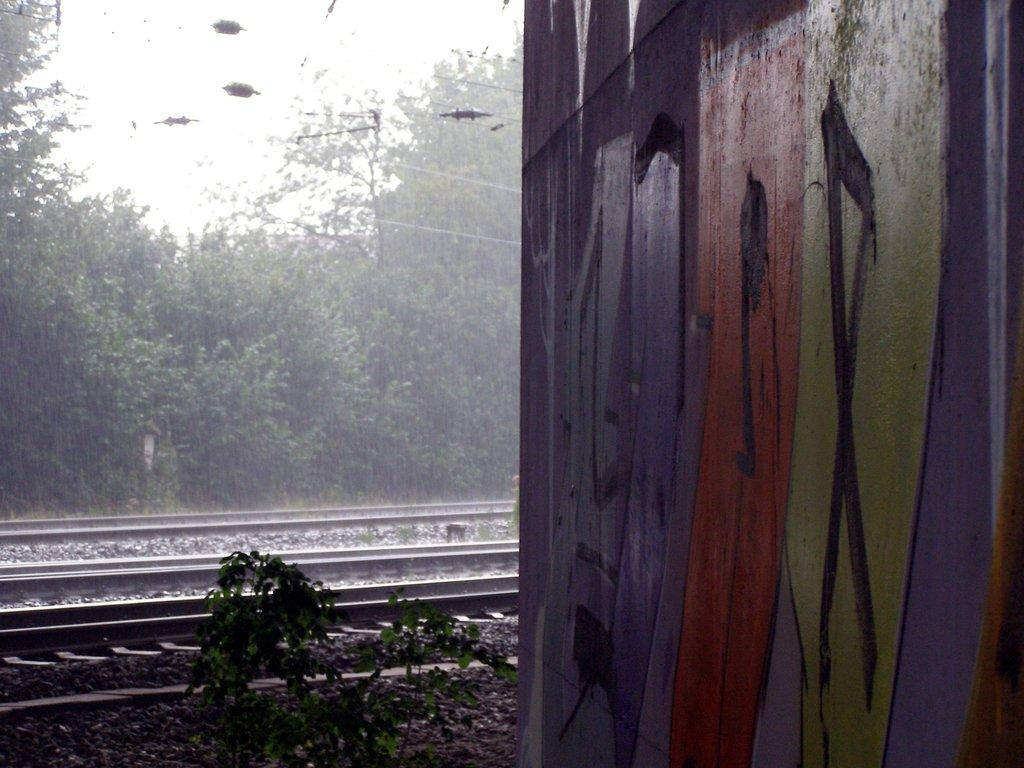What is depicted on the wall in the image? There is a wall with graffiti in the image. What can be seen in the background of the image? There is a railway track, a group of trees, plants, and the sky visible in the background of the image. What type of advertisement can be seen on the wall in the image? There is no advertisement present on the wall in the image; it features graffiti. Can you tell me how many tanks are visible in the image? There are no tanks present in the image. 